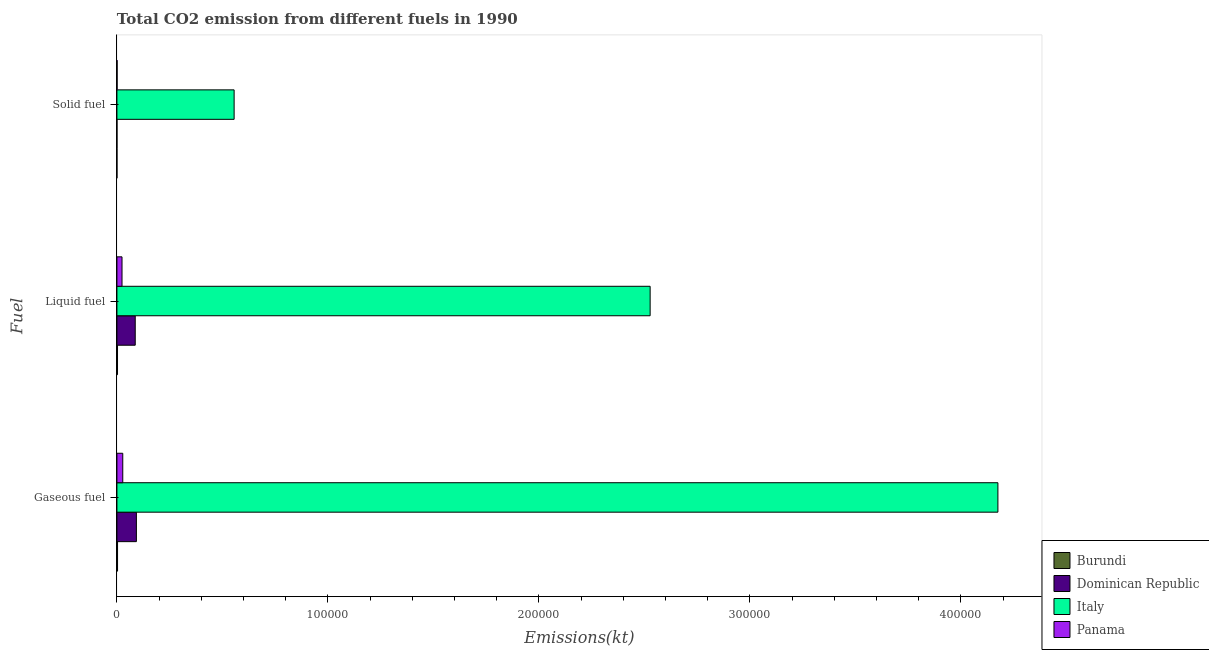Are the number of bars on each tick of the Y-axis equal?
Provide a short and direct response. Yes. What is the label of the 2nd group of bars from the top?
Give a very brief answer. Liquid fuel. What is the amount of co2 emissions from gaseous fuel in Burundi?
Your answer should be compact. 293.36. Across all countries, what is the maximum amount of co2 emissions from solid fuel?
Provide a succinct answer. 5.56e+04. Across all countries, what is the minimum amount of co2 emissions from liquid fuel?
Ensure brevity in your answer.  278.69. In which country was the amount of co2 emissions from gaseous fuel minimum?
Your response must be concise. Burundi. What is the total amount of co2 emissions from gaseous fuel in the graph?
Offer a terse response. 4.30e+05. What is the difference between the amount of co2 emissions from gaseous fuel in Burundi and that in Panama?
Provide a succinct answer. -2475.22. What is the difference between the amount of co2 emissions from liquid fuel in Italy and the amount of co2 emissions from gaseous fuel in Burundi?
Your answer should be compact. 2.52e+05. What is the average amount of co2 emissions from gaseous fuel per country?
Your response must be concise. 1.07e+05. What is the difference between the amount of co2 emissions from liquid fuel and amount of co2 emissions from solid fuel in Dominican Republic?
Your answer should be very brief. 8654.12. What is the ratio of the amount of co2 emissions from liquid fuel in Panama to that in Dominican Republic?
Make the answer very short. 0.28. Is the amount of co2 emissions from solid fuel in Panama less than that in Italy?
Provide a short and direct response. Yes. Is the difference between the amount of co2 emissions from gaseous fuel in Italy and Panama greater than the difference between the amount of co2 emissions from liquid fuel in Italy and Panama?
Make the answer very short. Yes. What is the difference between the highest and the second highest amount of co2 emissions from solid fuel?
Your answer should be compact. 5.55e+04. What is the difference between the highest and the lowest amount of co2 emissions from liquid fuel?
Provide a short and direct response. 2.52e+05. Is the sum of the amount of co2 emissions from solid fuel in Burundi and Panama greater than the maximum amount of co2 emissions from gaseous fuel across all countries?
Offer a terse response. No. What does the 4th bar from the top in Liquid fuel represents?
Offer a very short reply. Burundi. How many bars are there?
Your answer should be very brief. 12. How many countries are there in the graph?
Your answer should be compact. 4. Does the graph contain any zero values?
Offer a terse response. No. What is the title of the graph?
Provide a succinct answer. Total CO2 emission from different fuels in 1990. What is the label or title of the X-axis?
Offer a terse response. Emissions(kt). What is the label or title of the Y-axis?
Ensure brevity in your answer.  Fuel. What is the Emissions(kt) of Burundi in Gaseous fuel?
Offer a very short reply. 293.36. What is the Emissions(kt) in Dominican Republic in Gaseous fuel?
Provide a short and direct response. 9229.84. What is the Emissions(kt) of Italy in Gaseous fuel?
Your answer should be compact. 4.18e+05. What is the Emissions(kt) of Panama in Gaseous fuel?
Make the answer very short. 2768.59. What is the Emissions(kt) of Burundi in Liquid fuel?
Your response must be concise. 278.69. What is the Emissions(kt) in Dominican Republic in Liquid fuel?
Keep it short and to the point. 8679.79. What is the Emissions(kt) of Italy in Liquid fuel?
Offer a terse response. 2.53e+05. What is the Emissions(kt) in Panama in Liquid fuel?
Give a very brief answer. 2412.89. What is the Emissions(kt) in Burundi in Solid fuel?
Provide a short and direct response. 14.67. What is the Emissions(kt) of Dominican Republic in Solid fuel?
Offer a terse response. 25.67. What is the Emissions(kt) in Italy in Solid fuel?
Provide a short and direct response. 5.56e+04. What is the Emissions(kt) of Panama in Solid fuel?
Keep it short and to the point. 91.67. Across all Fuel, what is the maximum Emissions(kt) of Burundi?
Offer a very short reply. 293.36. Across all Fuel, what is the maximum Emissions(kt) of Dominican Republic?
Your response must be concise. 9229.84. Across all Fuel, what is the maximum Emissions(kt) of Italy?
Offer a terse response. 4.18e+05. Across all Fuel, what is the maximum Emissions(kt) of Panama?
Offer a terse response. 2768.59. Across all Fuel, what is the minimum Emissions(kt) of Burundi?
Your answer should be very brief. 14.67. Across all Fuel, what is the minimum Emissions(kt) of Dominican Republic?
Provide a succinct answer. 25.67. Across all Fuel, what is the minimum Emissions(kt) of Italy?
Offer a terse response. 5.56e+04. Across all Fuel, what is the minimum Emissions(kt) of Panama?
Offer a terse response. 91.67. What is the total Emissions(kt) in Burundi in the graph?
Offer a terse response. 586.72. What is the total Emissions(kt) in Dominican Republic in the graph?
Ensure brevity in your answer.  1.79e+04. What is the total Emissions(kt) in Italy in the graph?
Provide a short and direct response. 7.26e+05. What is the total Emissions(kt) of Panama in the graph?
Keep it short and to the point. 5273.15. What is the difference between the Emissions(kt) in Burundi in Gaseous fuel and that in Liquid fuel?
Ensure brevity in your answer.  14.67. What is the difference between the Emissions(kt) of Dominican Republic in Gaseous fuel and that in Liquid fuel?
Offer a terse response. 550.05. What is the difference between the Emissions(kt) of Italy in Gaseous fuel and that in Liquid fuel?
Your response must be concise. 1.65e+05. What is the difference between the Emissions(kt) of Panama in Gaseous fuel and that in Liquid fuel?
Make the answer very short. 355.7. What is the difference between the Emissions(kt) of Burundi in Gaseous fuel and that in Solid fuel?
Give a very brief answer. 278.69. What is the difference between the Emissions(kt) of Dominican Republic in Gaseous fuel and that in Solid fuel?
Provide a succinct answer. 9204.17. What is the difference between the Emissions(kt) in Italy in Gaseous fuel and that in Solid fuel?
Offer a terse response. 3.62e+05. What is the difference between the Emissions(kt) of Panama in Gaseous fuel and that in Solid fuel?
Your answer should be very brief. 2676.91. What is the difference between the Emissions(kt) of Burundi in Liquid fuel and that in Solid fuel?
Your answer should be compact. 264.02. What is the difference between the Emissions(kt) of Dominican Republic in Liquid fuel and that in Solid fuel?
Provide a short and direct response. 8654.12. What is the difference between the Emissions(kt) in Italy in Liquid fuel and that in Solid fuel?
Provide a succinct answer. 1.97e+05. What is the difference between the Emissions(kt) in Panama in Liquid fuel and that in Solid fuel?
Provide a succinct answer. 2321.21. What is the difference between the Emissions(kt) of Burundi in Gaseous fuel and the Emissions(kt) of Dominican Republic in Liquid fuel?
Provide a short and direct response. -8386.43. What is the difference between the Emissions(kt) of Burundi in Gaseous fuel and the Emissions(kt) of Italy in Liquid fuel?
Your answer should be compact. -2.52e+05. What is the difference between the Emissions(kt) of Burundi in Gaseous fuel and the Emissions(kt) of Panama in Liquid fuel?
Offer a very short reply. -2119.53. What is the difference between the Emissions(kt) in Dominican Republic in Gaseous fuel and the Emissions(kt) in Italy in Liquid fuel?
Your response must be concise. -2.43e+05. What is the difference between the Emissions(kt) in Dominican Republic in Gaseous fuel and the Emissions(kt) in Panama in Liquid fuel?
Give a very brief answer. 6816.95. What is the difference between the Emissions(kt) of Italy in Gaseous fuel and the Emissions(kt) of Panama in Liquid fuel?
Make the answer very short. 4.15e+05. What is the difference between the Emissions(kt) of Burundi in Gaseous fuel and the Emissions(kt) of Dominican Republic in Solid fuel?
Give a very brief answer. 267.69. What is the difference between the Emissions(kt) of Burundi in Gaseous fuel and the Emissions(kt) of Italy in Solid fuel?
Your answer should be very brief. -5.53e+04. What is the difference between the Emissions(kt) of Burundi in Gaseous fuel and the Emissions(kt) of Panama in Solid fuel?
Make the answer very short. 201.69. What is the difference between the Emissions(kt) in Dominican Republic in Gaseous fuel and the Emissions(kt) in Italy in Solid fuel?
Keep it short and to the point. -4.63e+04. What is the difference between the Emissions(kt) of Dominican Republic in Gaseous fuel and the Emissions(kt) of Panama in Solid fuel?
Make the answer very short. 9138.16. What is the difference between the Emissions(kt) of Italy in Gaseous fuel and the Emissions(kt) of Panama in Solid fuel?
Keep it short and to the point. 4.17e+05. What is the difference between the Emissions(kt) in Burundi in Liquid fuel and the Emissions(kt) in Dominican Republic in Solid fuel?
Provide a short and direct response. 253.02. What is the difference between the Emissions(kt) of Burundi in Liquid fuel and the Emissions(kt) of Italy in Solid fuel?
Provide a short and direct response. -5.53e+04. What is the difference between the Emissions(kt) of Burundi in Liquid fuel and the Emissions(kt) of Panama in Solid fuel?
Offer a very short reply. 187.02. What is the difference between the Emissions(kt) in Dominican Republic in Liquid fuel and the Emissions(kt) in Italy in Solid fuel?
Offer a terse response. -4.69e+04. What is the difference between the Emissions(kt) in Dominican Republic in Liquid fuel and the Emissions(kt) in Panama in Solid fuel?
Keep it short and to the point. 8588.11. What is the difference between the Emissions(kt) of Italy in Liquid fuel and the Emissions(kt) of Panama in Solid fuel?
Your answer should be very brief. 2.53e+05. What is the average Emissions(kt) of Burundi per Fuel?
Provide a short and direct response. 195.57. What is the average Emissions(kt) of Dominican Republic per Fuel?
Your answer should be compact. 5978.43. What is the average Emissions(kt) of Italy per Fuel?
Provide a succinct answer. 2.42e+05. What is the average Emissions(kt) in Panama per Fuel?
Your answer should be very brief. 1757.72. What is the difference between the Emissions(kt) of Burundi and Emissions(kt) of Dominican Republic in Gaseous fuel?
Offer a terse response. -8936.48. What is the difference between the Emissions(kt) of Burundi and Emissions(kt) of Italy in Gaseous fuel?
Offer a terse response. -4.17e+05. What is the difference between the Emissions(kt) of Burundi and Emissions(kt) of Panama in Gaseous fuel?
Provide a short and direct response. -2475.22. What is the difference between the Emissions(kt) of Dominican Republic and Emissions(kt) of Italy in Gaseous fuel?
Ensure brevity in your answer.  -4.08e+05. What is the difference between the Emissions(kt) in Dominican Republic and Emissions(kt) in Panama in Gaseous fuel?
Provide a short and direct response. 6461.25. What is the difference between the Emissions(kt) of Italy and Emissions(kt) of Panama in Gaseous fuel?
Your answer should be compact. 4.15e+05. What is the difference between the Emissions(kt) in Burundi and Emissions(kt) in Dominican Republic in Liquid fuel?
Provide a short and direct response. -8401.1. What is the difference between the Emissions(kt) of Burundi and Emissions(kt) of Italy in Liquid fuel?
Provide a succinct answer. -2.52e+05. What is the difference between the Emissions(kt) of Burundi and Emissions(kt) of Panama in Liquid fuel?
Provide a short and direct response. -2134.19. What is the difference between the Emissions(kt) of Dominican Republic and Emissions(kt) of Italy in Liquid fuel?
Your answer should be very brief. -2.44e+05. What is the difference between the Emissions(kt) of Dominican Republic and Emissions(kt) of Panama in Liquid fuel?
Provide a short and direct response. 6266.9. What is the difference between the Emissions(kt) of Italy and Emissions(kt) of Panama in Liquid fuel?
Offer a very short reply. 2.50e+05. What is the difference between the Emissions(kt) of Burundi and Emissions(kt) of Dominican Republic in Solid fuel?
Offer a very short reply. -11. What is the difference between the Emissions(kt) in Burundi and Emissions(kt) in Italy in Solid fuel?
Keep it short and to the point. -5.55e+04. What is the difference between the Emissions(kt) in Burundi and Emissions(kt) in Panama in Solid fuel?
Keep it short and to the point. -77.01. What is the difference between the Emissions(kt) in Dominican Republic and Emissions(kt) in Italy in Solid fuel?
Your answer should be very brief. -5.55e+04. What is the difference between the Emissions(kt) in Dominican Republic and Emissions(kt) in Panama in Solid fuel?
Ensure brevity in your answer.  -66.01. What is the difference between the Emissions(kt) in Italy and Emissions(kt) in Panama in Solid fuel?
Offer a very short reply. 5.55e+04. What is the ratio of the Emissions(kt) of Burundi in Gaseous fuel to that in Liquid fuel?
Your answer should be compact. 1.05. What is the ratio of the Emissions(kt) of Dominican Republic in Gaseous fuel to that in Liquid fuel?
Give a very brief answer. 1.06. What is the ratio of the Emissions(kt) of Italy in Gaseous fuel to that in Liquid fuel?
Keep it short and to the point. 1.65. What is the ratio of the Emissions(kt) of Panama in Gaseous fuel to that in Liquid fuel?
Your answer should be compact. 1.15. What is the ratio of the Emissions(kt) in Burundi in Gaseous fuel to that in Solid fuel?
Make the answer very short. 20. What is the ratio of the Emissions(kt) in Dominican Republic in Gaseous fuel to that in Solid fuel?
Your response must be concise. 359.57. What is the ratio of the Emissions(kt) in Italy in Gaseous fuel to that in Solid fuel?
Your answer should be very brief. 7.52. What is the ratio of the Emissions(kt) of Panama in Gaseous fuel to that in Solid fuel?
Your answer should be very brief. 30.2. What is the ratio of the Emissions(kt) in Dominican Republic in Liquid fuel to that in Solid fuel?
Offer a terse response. 338.14. What is the ratio of the Emissions(kt) of Italy in Liquid fuel to that in Solid fuel?
Your answer should be very brief. 4.55. What is the ratio of the Emissions(kt) in Panama in Liquid fuel to that in Solid fuel?
Provide a short and direct response. 26.32. What is the difference between the highest and the second highest Emissions(kt) of Burundi?
Provide a short and direct response. 14.67. What is the difference between the highest and the second highest Emissions(kt) in Dominican Republic?
Your response must be concise. 550.05. What is the difference between the highest and the second highest Emissions(kt) of Italy?
Offer a very short reply. 1.65e+05. What is the difference between the highest and the second highest Emissions(kt) in Panama?
Keep it short and to the point. 355.7. What is the difference between the highest and the lowest Emissions(kt) in Burundi?
Provide a short and direct response. 278.69. What is the difference between the highest and the lowest Emissions(kt) of Dominican Republic?
Ensure brevity in your answer.  9204.17. What is the difference between the highest and the lowest Emissions(kt) of Italy?
Give a very brief answer. 3.62e+05. What is the difference between the highest and the lowest Emissions(kt) in Panama?
Your answer should be very brief. 2676.91. 